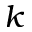<formula> <loc_0><loc_0><loc_500><loc_500>k</formula> 